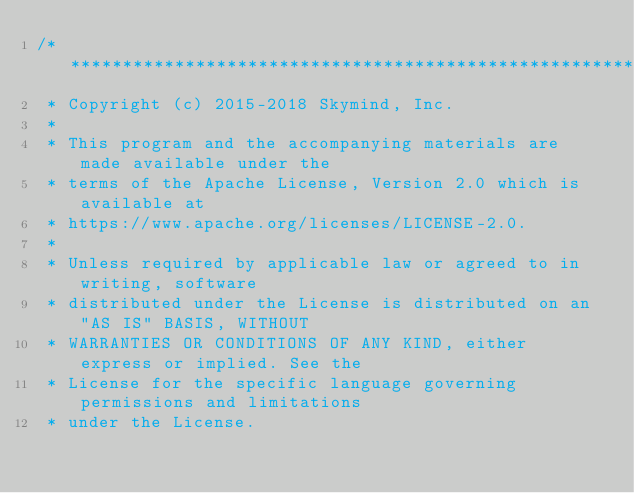Convert code to text. <code><loc_0><loc_0><loc_500><loc_500><_C++_>/*******************************************************************************
 * Copyright (c) 2015-2018 Skymind, Inc.
 *
 * This program and the accompanying materials are made available under the
 * terms of the Apache License, Version 2.0 which is available at
 * https://www.apache.org/licenses/LICENSE-2.0.
 *
 * Unless required by applicable law or agreed to in writing, software
 * distributed under the License is distributed on an "AS IS" BASIS, WITHOUT
 * WARRANTIES OR CONDITIONS OF ANY KIND, either express or implied. See the
 * License for the specific language governing permissions and limitations
 * under the License.</code> 